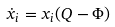Convert formula to latex. <formula><loc_0><loc_0><loc_500><loc_500>\dot { x } _ { i } = x _ { i } ( Q - \Phi )</formula> 